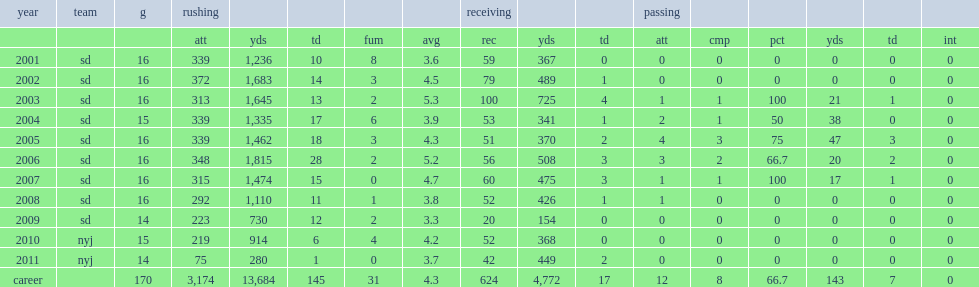How many yards did tomlinson run for, in his rookie season? 1236.0. 